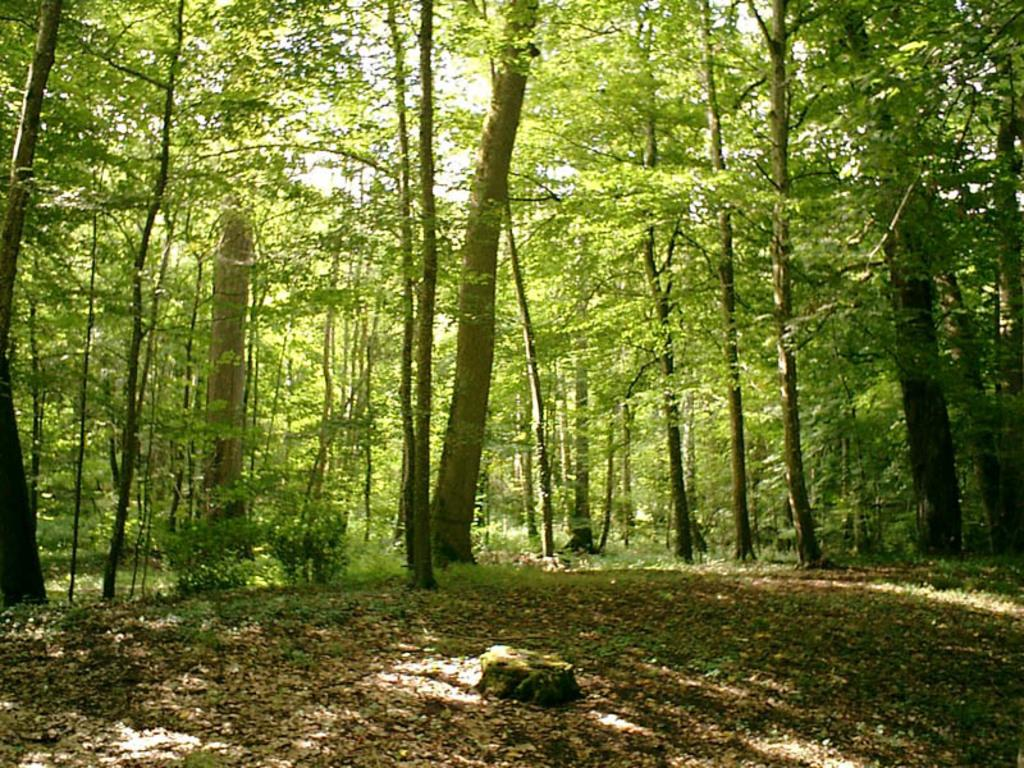What type of vegetation is present at the bottom of the image? There are dry leaves and grass at the bottom of the image. What can be seen in the background of the image? There is a group of trees in the background of the image. What type of quill is being used by the person sitting on the throne in the image? There is no person sitting on a throne in the image, nor is there a quill present. What season is depicted in the image, given the presence of dry leaves and grass? The image does not provide enough information to determine the season, as dry leaves and grass can be present in various seasons. 